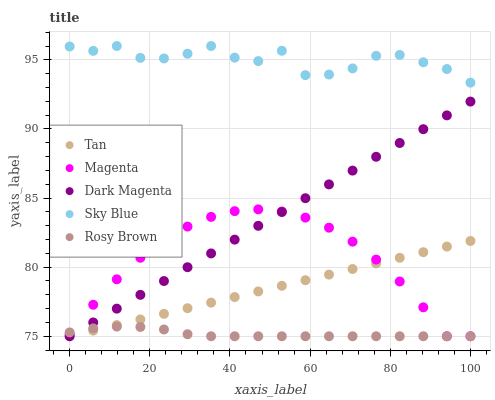Does Rosy Brown have the minimum area under the curve?
Answer yes or no. Yes. Does Sky Blue have the maximum area under the curve?
Answer yes or no. Yes. Does Tan have the minimum area under the curve?
Answer yes or no. No. Does Tan have the maximum area under the curve?
Answer yes or no. No. Is Tan the smoothest?
Answer yes or no. Yes. Is Sky Blue the roughest?
Answer yes or no. Yes. Is Rosy Brown the smoothest?
Answer yes or no. No. Is Rosy Brown the roughest?
Answer yes or no. No. Does Tan have the lowest value?
Answer yes or no. Yes. Does Sky Blue have the highest value?
Answer yes or no. Yes. Does Tan have the highest value?
Answer yes or no. No. Is Dark Magenta less than Sky Blue?
Answer yes or no. Yes. Is Sky Blue greater than Dark Magenta?
Answer yes or no. Yes. Does Rosy Brown intersect Dark Magenta?
Answer yes or no. Yes. Is Rosy Brown less than Dark Magenta?
Answer yes or no. No. Is Rosy Brown greater than Dark Magenta?
Answer yes or no. No. Does Dark Magenta intersect Sky Blue?
Answer yes or no. No. 